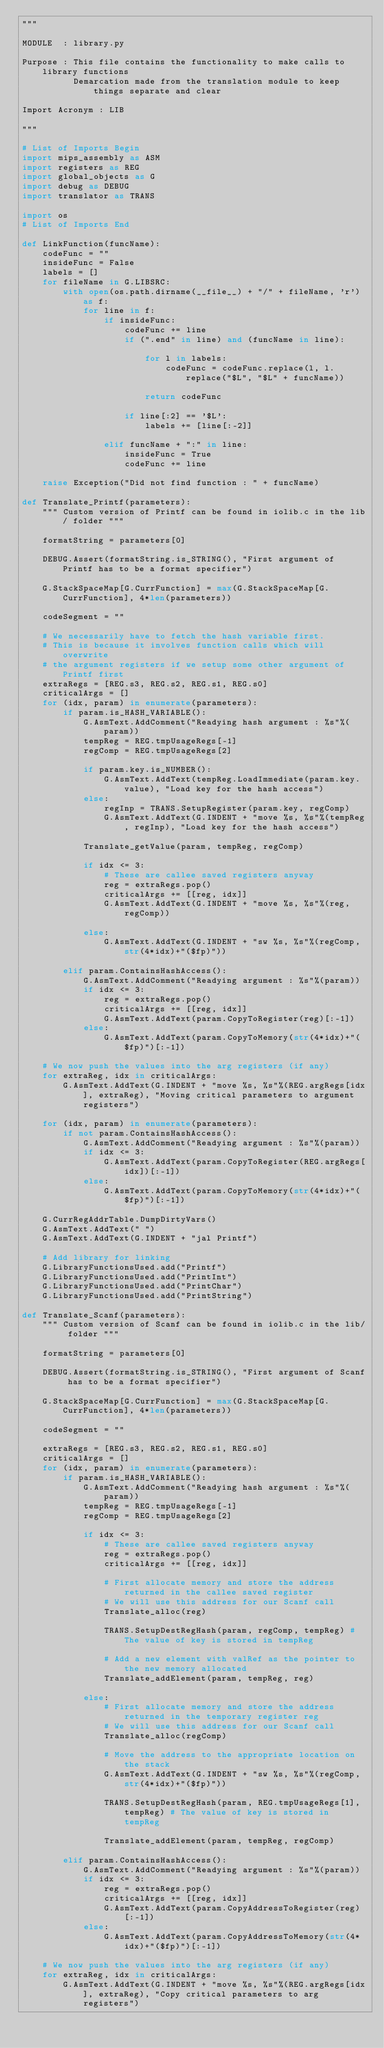Convert code to text. <code><loc_0><loc_0><loc_500><loc_500><_Python_>"""

MODULE  : library.py

Purpose : This file contains the functionality to make calls to library functions
          Demarcation made from the translation module to keep things separate and clear

Import Acronym : LIB

"""

# List of Imports Begin
import mips_assembly as ASM
import registers as REG
import global_objects as G
import debug as DEBUG
import translator as TRANS

import os
# List of Imports End

def LinkFunction(funcName):
    codeFunc = ""
    insideFunc = False
    labels = []
    for fileName in G.LIBSRC:
        with open(os.path.dirname(__file__) + "/" + fileName, 'r') as f:
            for line in f:
                if insideFunc:
                    codeFunc += line
                    if (".end" in line) and (funcName in line):

                        for l in labels:
                            codeFunc = codeFunc.replace(l, l.replace("$L", "$L" + funcName))

                        return codeFunc

                    if line[:2] == '$L':
                        labels += [line[:-2]]

                elif funcName + ":" in line:
                    insideFunc = True
                    codeFunc += line

    raise Exception("Did not find function : " + funcName)

def Translate_Printf(parameters):
    """ Custom version of Printf can be found in iolib.c in the lib/ folder """

    formatString = parameters[0]

    DEBUG.Assert(formatString.is_STRING(), "First argument of Printf has to be a format specifier")

    G.StackSpaceMap[G.CurrFunction] = max(G.StackSpaceMap[G.CurrFunction], 4*len(parameters))

    codeSegment = ""
    
    # We necessarily have to fetch the hash variable first.
    # This is because it involves function calls which will overwrite 
    # the argument registers if we setup some other argument of Printf first
    extraRegs = [REG.s3, REG.s2, REG.s1, REG.s0]
    criticalArgs = []
    for (idx, param) in enumerate(parameters):
        if param.is_HASH_VARIABLE():
            G.AsmText.AddComment("Readying hash argument : %s"%(param))
            tempReg = REG.tmpUsageRegs[-1]
            regComp = REG.tmpUsageRegs[2]

            if param.key.is_NUMBER():
                G.AsmText.AddText(tempReg.LoadImmediate(param.key.value), "Load key for the hash access")
            else:
                regInp = TRANS.SetupRegister(param.key, regComp)
                G.AsmText.AddText(G.INDENT + "move %s, %s"%(tempReg, regInp), "Load key for the hash access")

            Translate_getValue(param, tempReg, regComp) 

            if idx <= 3:
                # These are callee saved registers anyway
                reg = extraRegs.pop()
                criticalArgs += [[reg, idx]]
                G.AsmText.AddText(G.INDENT + "move %s, %s"%(reg, regComp))

            else:
                G.AsmText.AddText(G.INDENT + "sw %s, %s"%(regComp, str(4*idx)+"($fp)"))

        elif param.ContainsHashAccess():
            G.AsmText.AddComment("Readying argument : %s"%(param))
            if idx <= 3:
                reg = extraRegs.pop()
                criticalArgs += [[reg, idx]]
                G.AsmText.AddText(param.CopyToRegister(reg)[:-1])
            else:
                G.AsmText.AddText(param.CopyToMemory(str(4*idx)+"($fp)")[:-1])

    # We now push the values into the arg registers (if any)
    for extraReg, idx in criticalArgs:
        G.AsmText.AddText(G.INDENT + "move %s, %s"%(REG.argRegs[idx], extraReg), "Moving critical parameters to argument registers")

    for (idx, param) in enumerate(parameters):
        if not param.ContainsHashAccess():
            G.AsmText.AddComment("Readying argument : %s"%(param))
            if idx <= 3:
                G.AsmText.AddText(param.CopyToRegister(REG.argRegs[idx])[:-1])
            else:
                G.AsmText.AddText(param.CopyToMemory(str(4*idx)+"($fp)")[:-1])

    G.CurrRegAddrTable.DumpDirtyVars()
    G.AsmText.AddText(" ")
    G.AsmText.AddText(G.INDENT + "jal Printf")

    # Add library for linking
    G.LibraryFunctionsUsed.add("Printf")
    G.LibraryFunctionsUsed.add("PrintInt")
    G.LibraryFunctionsUsed.add("PrintChar")
    G.LibraryFunctionsUsed.add("PrintString")

def Translate_Scanf(parameters):
    """ Custom version of Scanf can be found in iolib.c in the lib/ folder """

    formatString = parameters[0]

    DEBUG.Assert(formatString.is_STRING(), "First argument of Scanf has to be a format specifier")

    G.StackSpaceMap[G.CurrFunction] = max(G.StackSpaceMap[G.CurrFunction], 4*len(parameters))

    codeSegment = ""

    extraRegs = [REG.s3, REG.s2, REG.s1, REG.s0]
    criticalArgs = []
    for (idx, param) in enumerate(parameters):
        if param.is_HASH_VARIABLE():
            G.AsmText.AddComment("Readying hash argument : %s"%(param))
            tempReg = REG.tmpUsageRegs[-1]
            regComp = REG.tmpUsageRegs[2]

            if idx <= 3:
                # These are callee saved registers anyway
                reg = extraRegs.pop()
                criticalArgs += [[reg, idx]]

                # First allocate memory and store the address returned in the callee saved register
                # We will use this address for our Scanf call
                Translate_alloc(reg)

                TRANS.SetupDestRegHash(param, regComp, tempReg) # The value of key is stored in tempReg

                # Add a new element with valRef as the pointer to the new memory allocated
                Translate_addElement(param, tempReg, reg)

            else:
                # First allocate memory and store the address returned in the temporary register reg
                # We will use this address for our Scanf call
                Translate_alloc(regComp)

                # Move the address to the appropriate location on the stack
                G.AsmText.AddText(G.INDENT + "sw %s, %s"%(regComp, str(4*idx)+"($fp)"))

                TRANS.SetupDestRegHash(param, REG.tmpUsageRegs[1], tempReg) # The value of key is stored in tempReg

                Translate_addElement(param, tempReg, regComp)

        elif param.ContainsHashAccess():
            G.AsmText.AddComment("Readying argument : %s"%(param))
            if idx <= 3:
                reg = extraRegs.pop()
                criticalArgs += [[reg, idx]]
                G.AsmText.AddText(param.CopyAddressToRegister(reg)[:-1])
            else:
                G.AsmText.AddText(param.CopyAddressToMemory(str(4*idx)+"($fp)")[:-1])

    # We now push the values into the arg registers (if any)
    for extraReg, idx in criticalArgs:
        G.AsmText.AddText(G.INDENT + "move %s, %s"%(REG.argRegs[idx], extraReg), "Copy critical parameters to arg registers")
</code> 